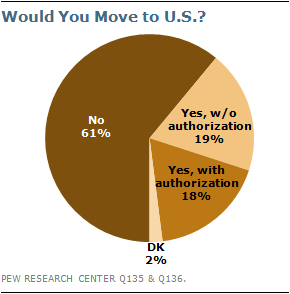List a handful of essential elements in this visual. The number is no larger than DK, and it is approximately 30.5. 